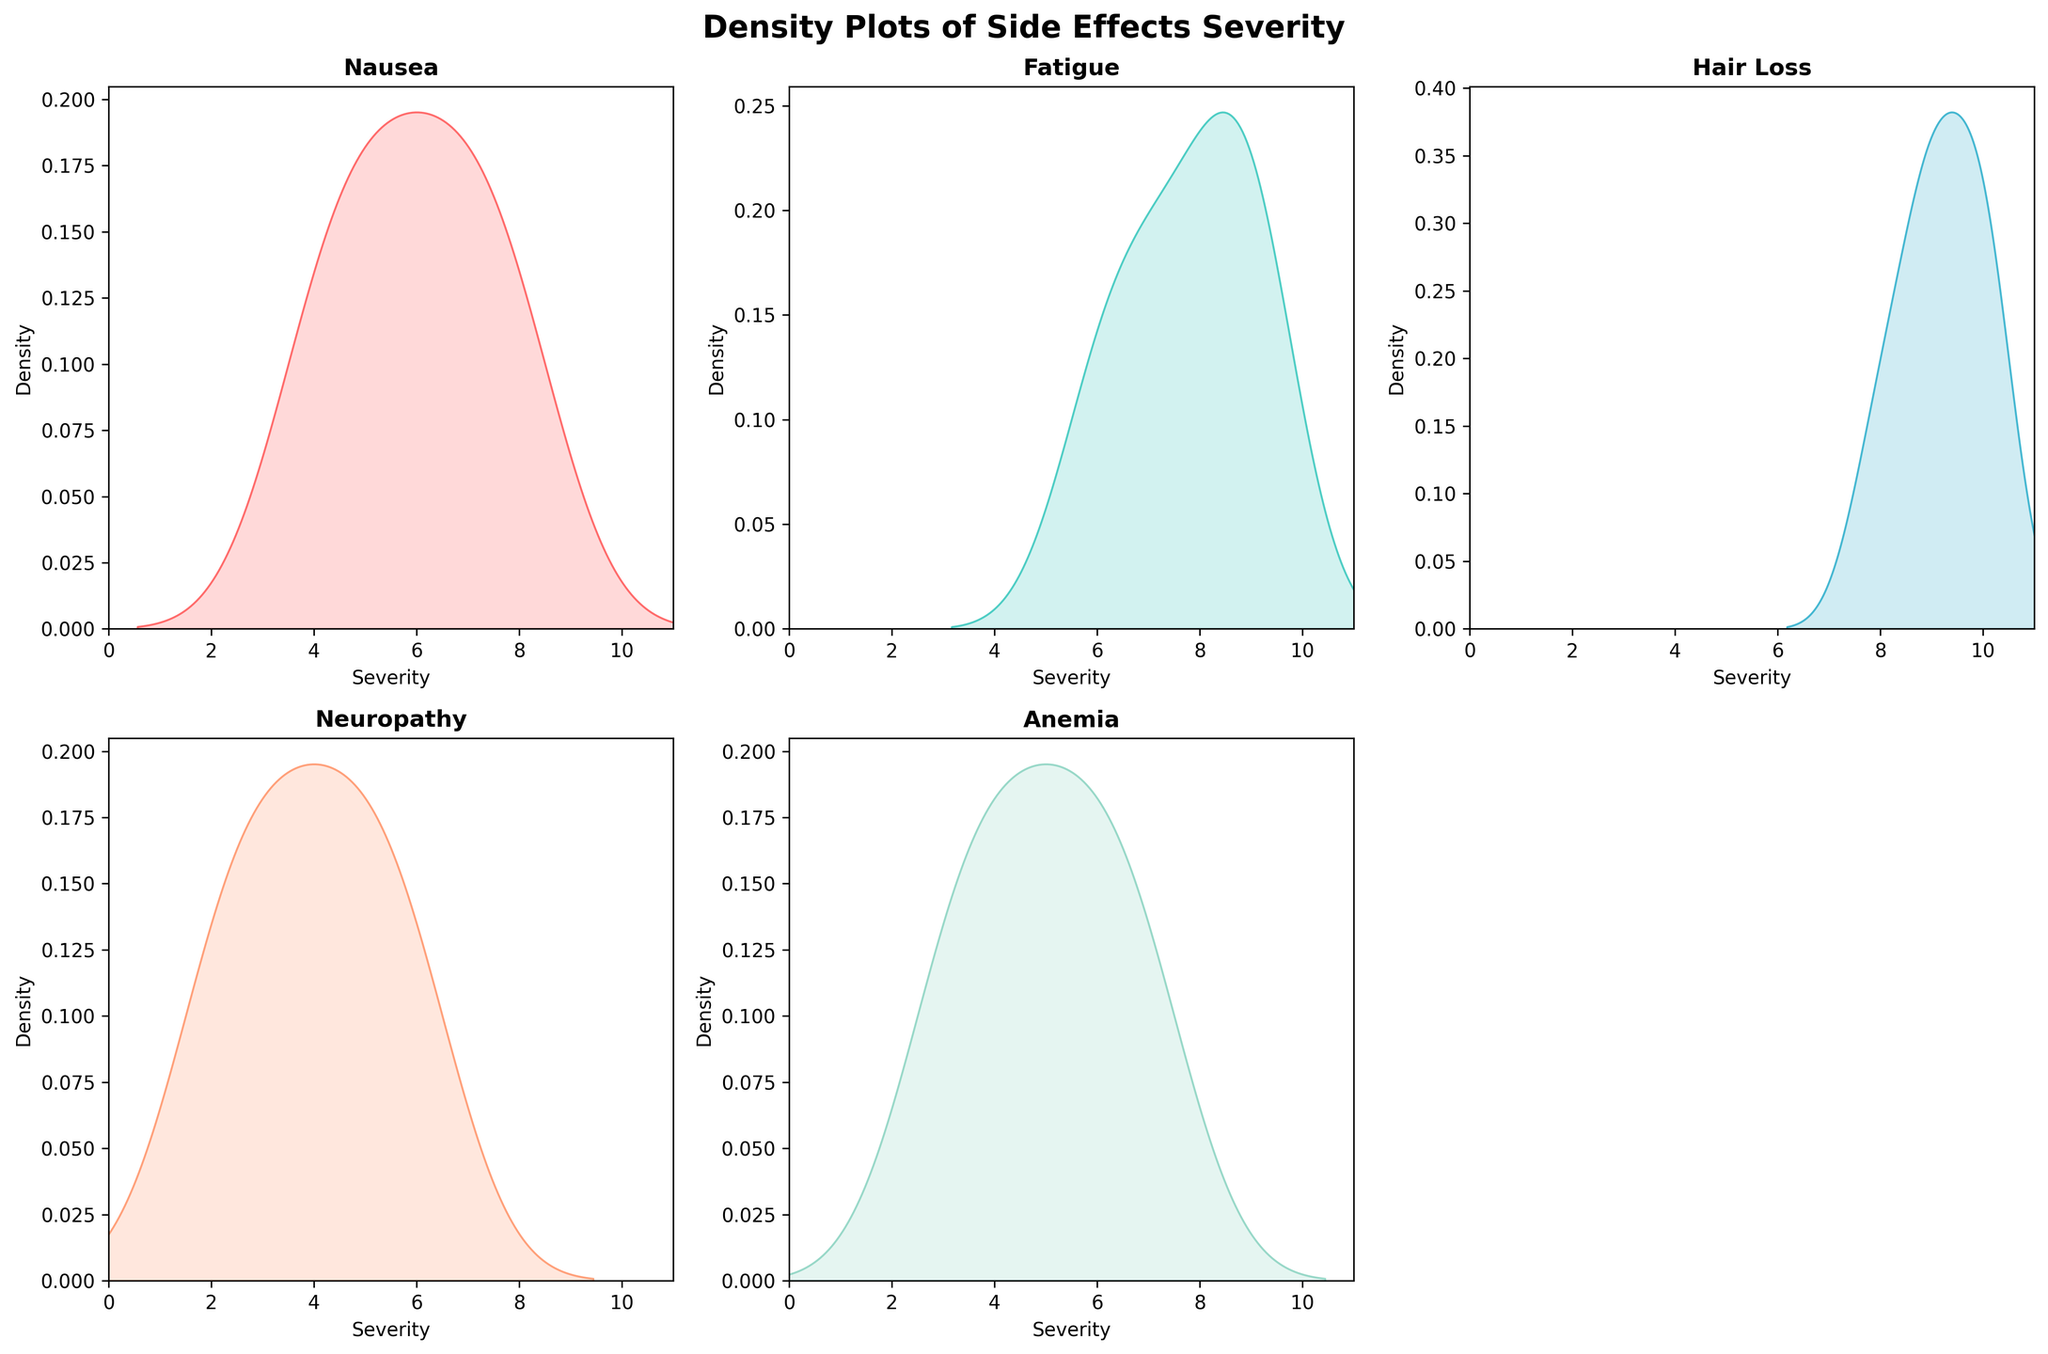How many side effects are plotted in the figure? The figure has individual density plots for each unique side effect. Looking at the titles of each subplot will give the count of side effects.
Answer: 5 Which side effect has the highest severity density peak? To find the highest severity density peak, examine each subplot to see which one has the tallest peak value along the y-axis.
Answer: Hair Loss For which side effect is the severity range the widest? Check the width of the curves for each side effect, noting how spread out the values are along the x-axis from the leftmost to the rightmost points.
Answer: Neuropathy Compare the median severity of Nausea and Anemia. Which one is higher? To determine the median, locate where around the middle of the density curves lies. For more precision, consider the peak and how the data is distributed around it.
Answer: Nausea Which side effect has the most concentrated density near the highest severity levels? Identify the side effect where the majority of the density (peak area of the curve) is close to the higher end of the severity scale (closer to 10).
Answer: Hair Loss How does the severity distribution of Fatigue compare to that of Hair Loss? Compare the density curves of Fatigue and Hair Loss by examining their peak positions, widths, and overall spread. Specifically, note if one is shifted more towards higher or lower severities.
Answer: Hair Loss is more concentrated at higher severity levels What is the range of severity levels observed for Neuropathy? Look at the Neuropathy subplot and identify the range on the x-axis where the density curve exists from start to end.
Answer: 2 to 6 Is the severity of any side effect distributed almost uniformly? Check each subplot to determine if any side effect has a relatively flat curve, indicating a more uniform distribution of severity levels.
Answer: No In terms of density shape, which side effect’s severity shows a bimodal distribution? A bimodal distribution shows two peaks in the density curve. Scan through each subplot to identify if any side effect shows this characteristic.
Answer: None Which side effect shows the least severe densities concentrated below severity level 5? Observe the density plots and identify which side effect has the most area under the curve concentrated below the severity level 5 on the x-axis.
Answer: Neuropathy 